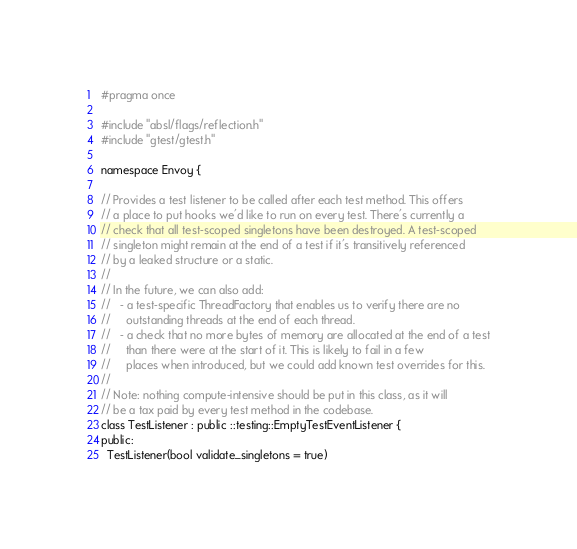Convert code to text. <code><loc_0><loc_0><loc_500><loc_500><_C_>#pragma once

#include "absl/flags/reflection.h"
#include "gtest/gtest.h"

namespace Envoy {

// Provides a test listener to be called after each test method. This offers
// a place to put hooks we'd like to run on every test. There's currently a
// check that all test-scoped singletons have been destroyed. A test-scoped
// singleton might remain at the end of a test if it's transitively referenced
// by a leaked structure or a static.
//
// In the future, we can also add:
//   - a test-specific ThreadFactory that enables us to verify there are no
//     outstanding threads at the end of each thread.
//   - a check that no more bytes of memory are allocated at the end of a test
//     than there were at the start of it. This is likely to fail in a few
//     places when introduced, but we could add known test overrides for this.
//
// Note: nothing compute-intensive should be put in this class, as it will
// be a tax paid by every test method in the codebase.
class TestListener : public ::testing::EmptyTestEventListener {
public:
  TestListener(bool validate_singletons = true)</code> 